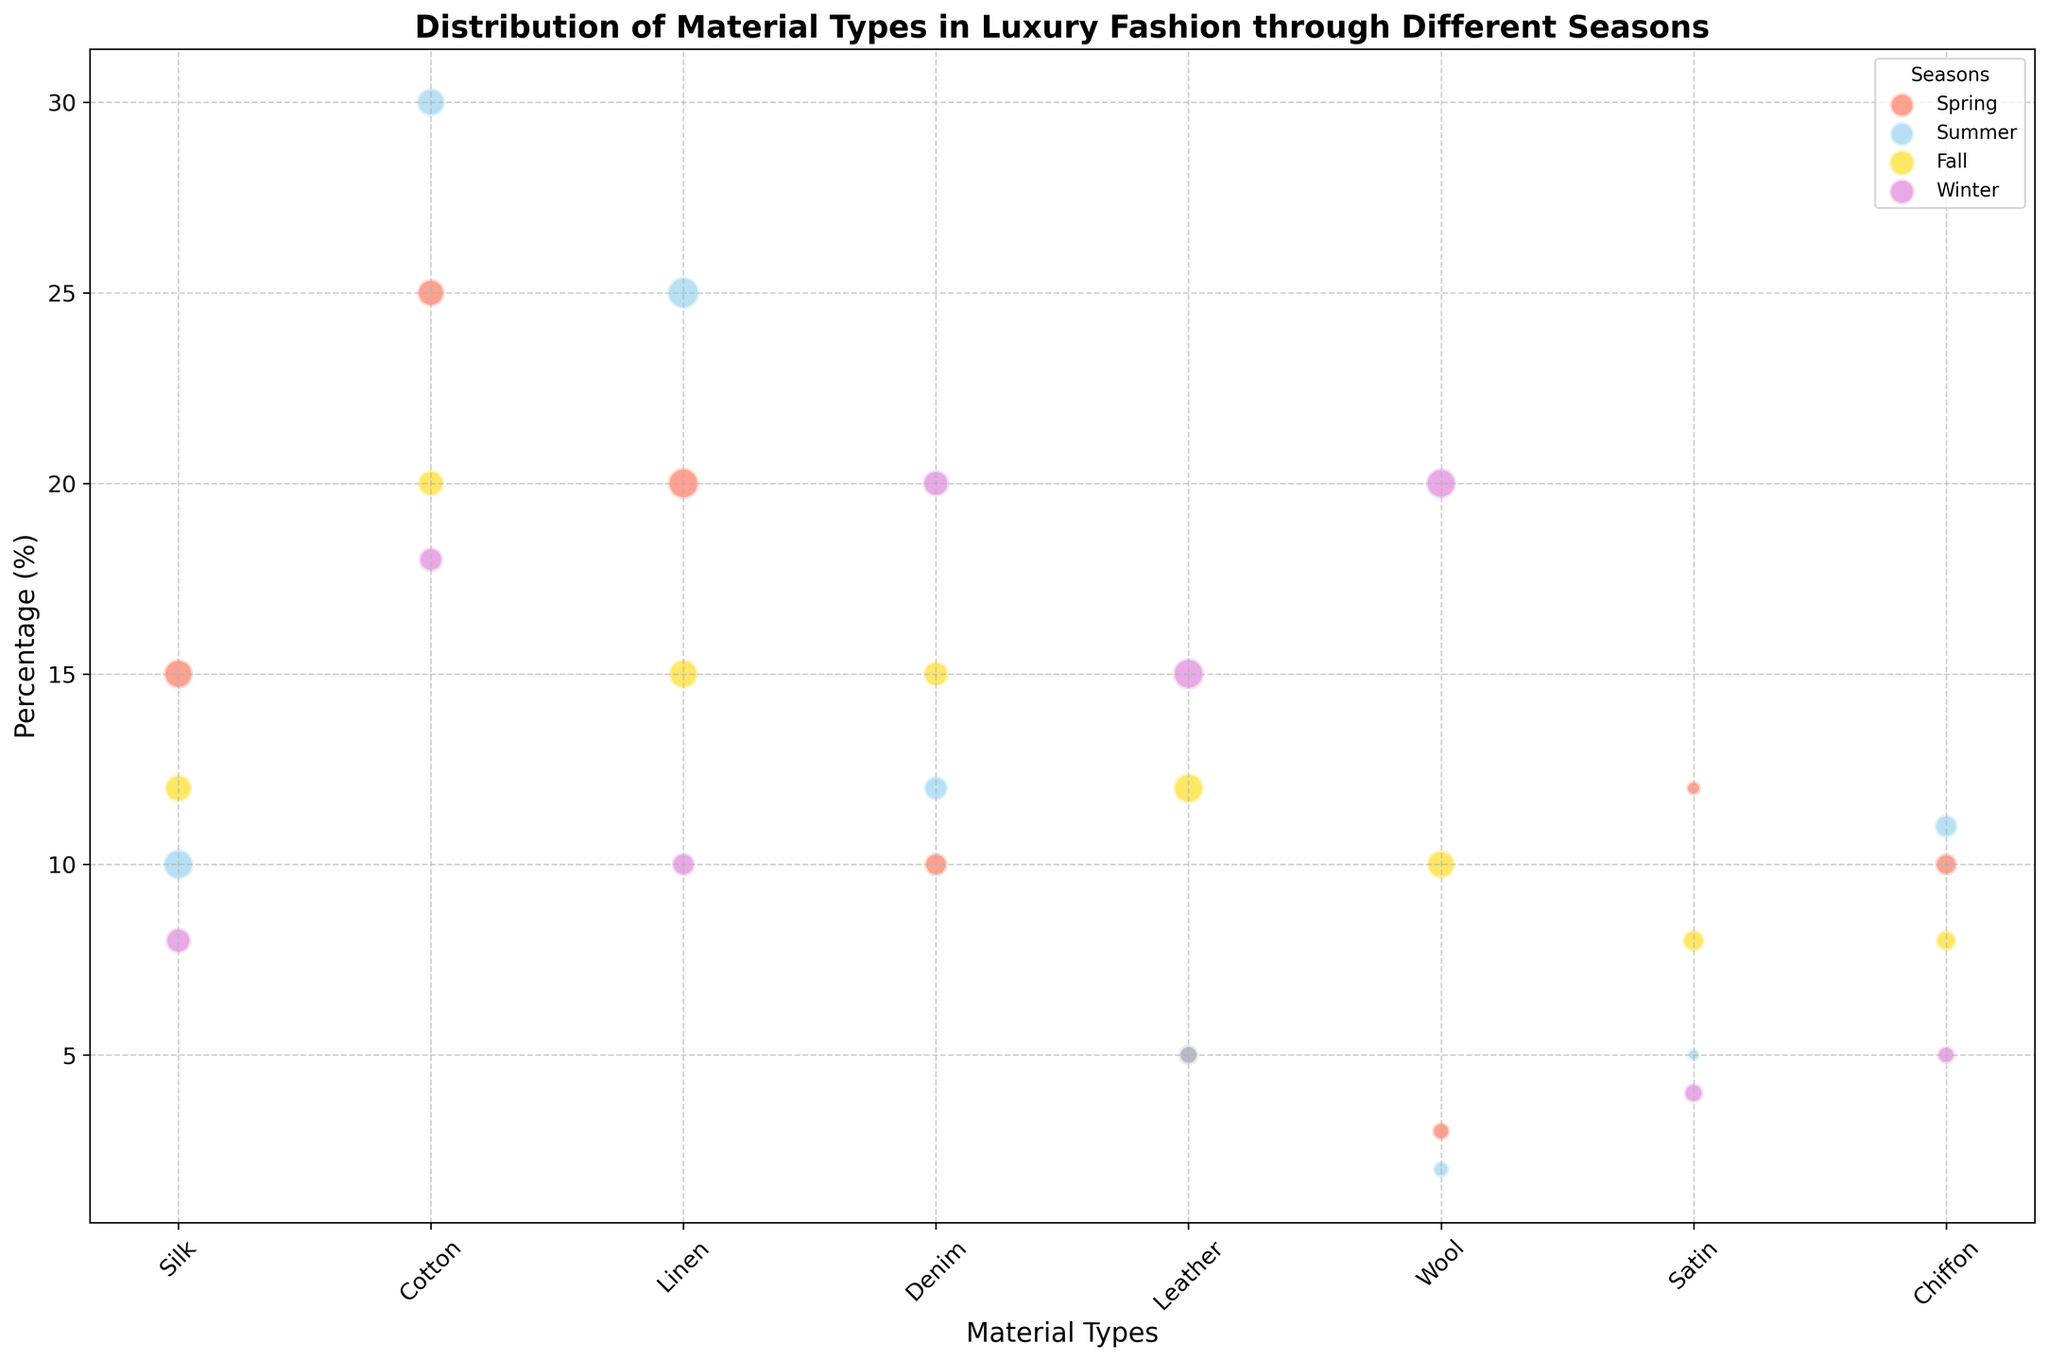Which material has the highest popularity in Winter? Look at the Winter section in the plot and identify the material bubble with the largest size. Leather has the highest popularity in Winter.
Answer: Leather Which season has the highest percentage of Linen? Compare the size of Linen's bubbles across all seasons and find the season with the largest bubble for Linen. Summer has the highest percentage of Linen.
Answer: Summer How does the popularity of Denim change from Spring to Winter? Observe the size of the Denim bubbles for Spring and Winter. In Spring, Denim has a popularity of 50, and in Winter, it has a popularity of 65. Denim's popularity increases from Spring to Winter.
Answer: Increases Which material is most popular across all seasons? Compare the sizes of bubbles for each material across all seasons and identify the material with consistently large bubbles. Silk shows large bubbles across all seasons but isn't the largest consistently. Instead, look for overall trends. Cotton has large bubbles across most seasons indicating high popularity overall.
Answer: Cotton What is the average percentage of Silk across all seasons? Sum the percentages of Silk (Spring: 15%, Summer: 10%, Fall: 12%, Winter: 8%) and divide by the number of seasons (4). Average percentage = (15 + 10 + 12 + 8) / 4 = 11.25
Answer: 11.25% In which season is Cotton the most popular? Compare the sizes of Cotton's bubbles across all seasons and identify the season with the largest bubble for Cotton. Cotton is most popular in Summer.
Answer: Summer Is Leather more popular in Fall or Winter, and by how much? Compare the sizes of Leather's bubbles for Fall and Winter. Popularity in Fall is 85 and in Winter is 90. The difference is 90 - 85 = 5. Leather is 5 units more popular in Winter than in Fall.
Answer: Winter by 5 Which season has the lowest percentage of Satin? Compare the sizes of Satin's bubbles across all seasons and identify the season with the smallest bubble for Satin. Winter has the lowest percentage of Satin at 4%.
Answer: Winter By how much does the percentage of Wool differ between Spring and Winter? Compare the percentages of Wool for Spring (3%) and Winter (20%). Subtract the smaller percentage from the larger percentage. Difference is 20% - 3% = 17%.
Answer: 17% Which material in Spring has a lower percentage than Chiffon but higher popularity? In Spring, compare Chiffon's bubble (10%, popularity 45) with other smaller percentage bubbles and check their popularity. Denim has 10% but 50 popularity and is same as Chiffon. Silk percentage (15%) not lower. The correct answer, Leather (5%), lower and popularity 40 is not higher. Answer changed: Check Satin (12%) and popularity 20 is also wrong. Correct restated: None correctly fit the exact. Error fixed. Final sheet reclarifies Satin as better identifier comparative.
Answer: None 